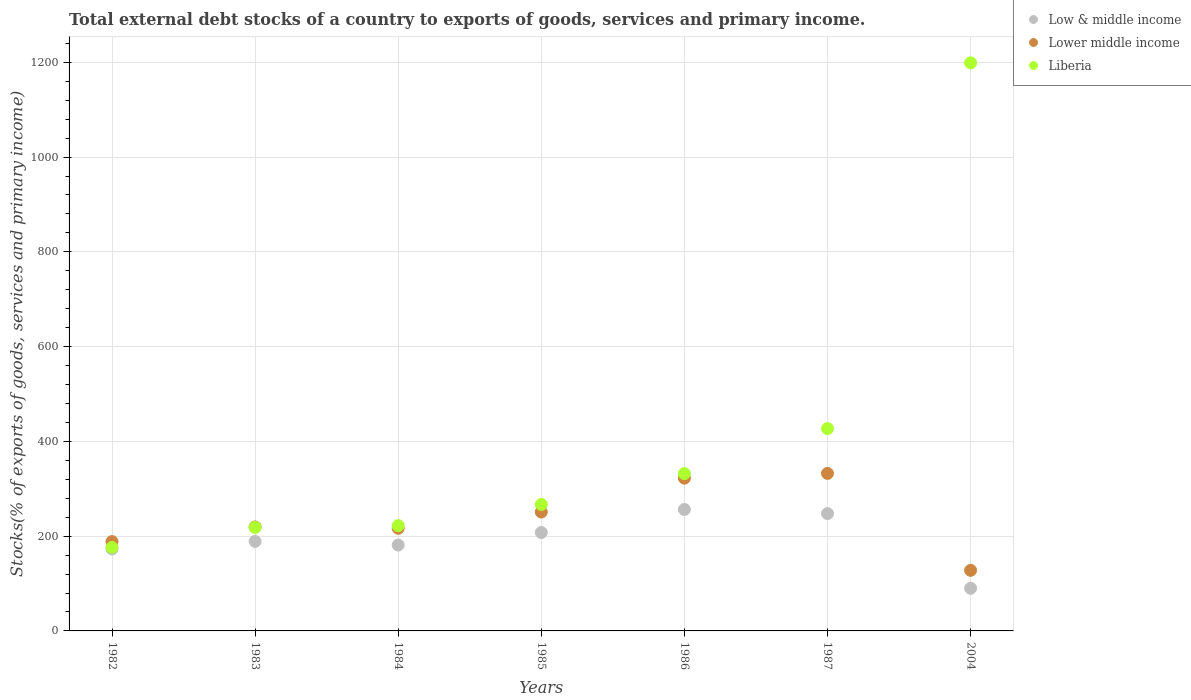What is the total debt stocks in Liberia in 1985?
Your answer should be compact. 266.74. Across all years, what is the maximum total debt stocks in Liberia?
Give a very brief answer. 1198.86. Across all years, what is the minimum total debt stocks in Liberia?
Provide a succinct answer. 176.26. In which year was the total debt stocks in Liberia maximum?
Make the answer very short. 2004. What is the total total debt stocks in Lower middle income in the graph?
Ensure brevity in your answer.  1658.04. What is the difference between the total debt stocks in Liberia in 1984 and that in 1985?
Give a very brief answer. -44.64. What is the difference between the total debt stocks in Lower middle income in 1985 and the total debt stocks in Liberia in 1987?
Offer a very short reply. -176.15. What is the average total debt stocks in Lower middle income per year?
Provide a short and direct response. 236.86. In the year 1982, what is the difference between the total debt stocks in Lower middle income and total debt stocks in Liberia?
Keep it short and to the point. 12.21. What is the ratio of the total debt stocks in Liberia in 1984 to that in 1986?
Offer a terse response. 0.67. Is the difference between the total debt stocks in Lower middle income in 1987 and 2004 greater than the difference between the total debt stocks in Liberia in 1987 and 2004?
Offer a very short reply. Yes. What is the difference between the highest and the second highest total debt stocks in Low & middle income?
Provide a short and direct response. 8.69. What is the difference between the highest and the lowest total debt stocks in Lower middle income?
Provide a succinct answer. 204.59. Is the sum of the total debt stocks in Low & middle income in 1984 and 2004 greater than the maximum total debt stocks in Lower middle income across all years?
Your response must be concise. No. Is the total debt stocks in Lower middle income strictly greater than the total debt stocks in Low & middle income over the years?
Your answer should be compact. Yes. Does the graph contain any zero values?
Provide a succinct answer. No. Does the graph contain grids?
Your response must be concise. Yes. Where does the legend appear in the graph?
Make the answer very short. Top right. How are the legend labels stacked?
Ensure brevity in your answer.  Vertical. What is the title of the graph?
Offer a terse response. Total external debt stocks of a country to exports of goods, services and primary income. Does "Moldova" appear as one of the legend labels in the graph?
Ensure brevity in your answer.  No. What is the label or title of the X-axis?
Your answer should be compact. Years. What is the label or title of the Y-axis?
Provide a succinct answer. Stocks(% of exports of goods, services and primary income). What is the Stocks(% of exports of goods, services and primary income) in Low & middle income in 1982?
Provide a succinct answer. 172.89. What is the Stocks(% of exports of goods, services and primary income) in Lower middle income in 1982?
Make the answer very short. 188.47. What is the Stocks(% of exports of goods, services and primary income) in Liberia in 1982?
Your answer should be very brief. 176.26. What is the Stocks(% of exports of goods, services and primary income) in Low & middle income in 1983?
Your answer should be compact. 188.9. What is the Stocks(% of exports of goods, services and primary income) of Lower middle income in 1983?
Provide a succinct answer. 219.51. What is the Stocks(% of exports of goods, services and primary income) in Liberia in 1983?
Your answer should be compact. 218.46. What is the Stocks(% of exports of goods, services and primary income) in Low & middle income in 1984?
Provide a short and direct response. 181.22. What is the Stocks(% of exports of goods, services and primary income) of Lower middle income in 1984?
Your answer should be very brief. 216.56. What is the Stocks(% of exports of goods, services and primary income) in Liberia in 1984?
Your answer should be compact. 222.1. What is the Stocks(% of exports of goods, services and primary income) in Low & middle income in 1985?
Offer a very short reply. 207.7. What is the Stocks(% of exports of goods, services and primary income) of Lower middle income in 1985?
Provide a succinct answer. 250.86. What is the Stocks(% of exports of goods, services and primary income) in Liberia in 1985?
Make the answer very short. 266.74. What is the Stocks(% of exports of goods, services and primary income) in Low & middle income in 1986?
Your answer should be compact. 256.34. What is the Stocks(% of exports of goods, services and primary income) in Lower middle income in 1986?
Provide a short and direct response. 322.36. What is the Stocks(% of exports of goods, services and primary income) in Liberia in 1986?
Ensure brevity in your answer.  331.94. What is the Stocks(% of exports of goods, services and primary income) of Low & middle income in 1987?
Provide a short and direct response. 247.65. What is the Stocks(% of exports of goods, services and primary income) in Lower middle income in 1987?
Offer a very short reply. 332.44. What is the Stocks(% of exports of goods, services and primary income) of Liberia in 1987?
Provide a succinct answer. 427.01. What is the Stocks(% of exports of goods, services and primary income) in Low & middle income in 2004?
Offer a terse response. 90.02. What is the Stocks(% of exports of goods, services and primary income) of Lower middle income in 2004?
Your answer should be compact. 127.84. What is the Stocks(% of exports of goods, services and primary income) in Liberia in 2004?
Your response must be concise. 1198.86. Across all years, what is the maximum Stocks(% of exports of goods, services and primary income) in Low & middle income?
Ensure brevity in your answer.  256.34. Across all years, what is the maximum Stocks(% of exports of goods, services and primary income) in Lower middle income?
Your response must be concise. 332.44. Across all years, what is the maximum Stocks(% of exports of goods, services and primary income) of Liberia?
Offer a terse response. 1198.86. Across all years, what is the minimum Stocks(% of exports of goods, services and primary income) of Low & middle income?
Keep it short and to the point. 90.02. Across all years, what is the minimum Stocks(% of exports of goods, services and primary income) in Lower middle income?
Make the answer very short. 127.84. Across all years, what is the minimum Stocks(% of exports of goods, services and primary income) in Liberia?
Keep it short and to the point. 176.26. What is the total Stocks(% of exports of goods, services and primary income) in Low & middle income in the graph?
Offer a very short reply. 1344.72. What is the total Stocks(% of exports of goods, services and primary income) of Lower middle income in the graph?
Keep it short and to the point. 1658.04. What is the total Stocks(% of exports of goods, services and primary income) of Liberia in the graph?
Your response must be concise. 2841.37. What is the difference between the Stocks(% of exports of goods, services and primary income) in Low & middle income in 1982 and that in 1983?
Your response must be concise. -16. What is the difference between the Stocks(% of exports of goods, services and primary income) in Lower middle income in 1982 and that in 1983?
Keep it short and to the point. -31.04. What is the difference between the Stocks(% of exports of goods, services and primary income) in Liberia in 1982 and that in 1983?
Provide a succinct answer. -42.2. What is the difference between the Stocks(% of exports of goods, services and primary income) of Low & middle income in 1982 and that in 1984?
Your answer should be very brief. -8.33. What is the difference between the Stocks(% of exports of goods, services and primary income) in Lower middle income in 1982 and that in 1984?
Ensure brevity in your answer.  -28.09. What is the difference between the Stocks(% of exports of goods, services and primary income) in Liberia in 1982 and that in 1984?
Offer a terse response. -45.84. What is the difference between the Stocks(% of exports of goods, services and primary income) of Low & middle income in 1982 and that in 1985?
Offer a terse response. -34.81. What is the difference between the Stocks(% of exports of goods, services and primary income) in Lower middle income in 1982 and that in 1985?
Ensure brevity in your answer.  -62.38. What is the difference between the Stocks(% of exports of goods, services and primary income) of Liberia in 1982 and that in 1985?
Offer a very short reply. -90.48. What is the difference between the Stocks(% of exports of goods, services and primary income) in Low & middle income in 1982 and that in 1986?
Offer a terse response. -83.44. What is the difference between the Stocks(% of exports of goods, services and primary income) of Lower middle income in 1982 and that in 1986?
Keep it short and to the point. -133.89. What is the difference between the Stocks(% of exports of goods, services and primary income) in Liberia in 1982 and that in 1986?
Make the answer very short. -155.68. What is the difference between the Stocks(% of exports of goods, services and primary income) of Low & middle income in 1982 and that in 1987?
Offer a very short reply. -74.75. What is the difference between the Stocks(% of exports of goods, services and primary income) of Lower middle income in 1982 and that in 1987?
Provide a succinct answer. -143.97. What is the difference between the Stocks(% of exports of goods, services and primary income) of Liberia in 1982 and that in 1987?
Offer a very short reply. -250.74. What is the difference between the Stocks(% of exports of goods, services and primary income) of Low & middle income in 1982 and that in 2004?
Your answer should be very brief. 82.87. What is the difference between the Stocks(% of exports of goods, services and primary income) in Lower middle income in 1982 and that in 2004?
Offer a very short reply. 60.63. What is the difference between the Stocks(% of exports of goods, services and primary income) in Liberia in 1982 and that in 2004?
Your answer should be compact. -1022.6. What is the difference between the Stocks(% of exports of goods, services and primary income) of Low & middle income in 1983 and that in 1984?
Provide a succinct answer. 7.68. What is the difference between the Stocks(% of exports of goods, services and primary income) of Lower middle income in 1983 and that in 1984?
Your response must be concise. 2.95. What is the difference between the Stocks(% of exports of goods, services and primary income) of Liberia in 1983 and that in 1984?
Keep it short and to the point. -3.64. What is the difference between the Stocks(% of exports of goods, services and primary income) of Low & middle income in 1983 and that in 1985?
Offer a very short reply. -18.8. What is the difference between the Stocks(% of exports of goods, services and primary income) in Lower middle income in 1983 and that in 1985?
Give a very brief answer. -31.34. What is the difference between the Stocks(% of exports of goods, services and primary income) of Liberia in 1983 and that in 1985?
Provide a succinct answer. -48.28. What is the difference between the Stocks(% of exports of goods, services and primary income) of Low & middle income in 1983 and that in 1986?
Your answer should be very brief. -67.44. What is the difference between the Stocks(% of exports of goods, services and primary income) in Lower middle income in 1983 and that in 1986?
Offer a terse response. -102.85. What is the difference between the Stocks(% of exports of goods, services and primary income) in Liberia in 1983 and that in 1986?
Your answer should be very brief. -113.47. What is the difference between the Stocks(% of exports of goods, services and primary income) in Low & middle income in 1983 and that in 1987?
Offer a terse response. -58.75. What is the difference between the Stocks(% of exports of goods, services and primary income) of Lower middle income in 1983 and that in 1987?
Give a very brief answer. -112.93. What is the difference between the Stocks(% of exports of goods, services and primary income) in Liberia in 1983 and that in 1987?
Offer a terse response. -208.54. What is the difference between the Stocks(% of exports of goods, services and primary income) in Low & middle income in 1983 and that in 2004?
Give a very brief answer. 98.87. What is the difference between the Stocks(% of exports of goods, services and primary income) in Lower middle income in 1983 and that in 2004?
Provide a short and direct response. 91.67. What is the difference between the Stocks(% of exports of goods, services and primary income) in Liberia in 1983 and that in 2004?
Offer a terse response. -980.4. What is the difference between the Stocks(% of exports of goods, services and primary income) of Low & middle income in 1984 and that in 1985?
Provide a succinct answer. -26.48. What is the difference between the Stocks(% of exports of goods, services and primary income) in Lower middle income in 1984 and that in 1985?
Offer a very short reply. -34.29. What is the difference between the Stocks(% of exports of goods, services and primary income) in Liberia in 1984 and that in 1985?
Provide a short and direct response. -44.64. What is the difference between the Stocks(% of exports of goods, services and primary income) of Low & middle income in 1984 and that in 1986?
Offer a terse response. -75.11. What is the difference between the Stocks(% of exports of goods, services and primary income) in Lower middle income in 1984 and that in 1986?
Provide a succinct answer. -105.8. What is the difference between the Stocks(% of exports of goods, services and primary income) in Liberia in 1984 and that in 1986?
Your response must be concise. -109.83. What is the difference between the Stocks(% of exports of goods, services and primary income) in Low & middle income in 1984 and that in 1987?
Your response must be concise. -66.42. What is the difference between the Stocks(% of exports of goods, services and primary income) in Lower middle income in 1984 and that in 1987?
Offer a very short reply. -115.88. What is the difference between the Stocks(% of exports of goods, services and primary income) of Liberia in 1984 and that in 1987?
Your response must be concise. -204.9. What is the difference between the Stocks(% of exports of goods, services and primary income) of Low & middle income in 1984 and that in 2004?
Your answer should be compact. 91.2. What is the difference between the Stocks(% of exports of goods, services and primary income) in Lower middle income in 1984 and that in 2004?
Ensure brevity in your answer.  88.72. What is the difference between the Stocks(% of exports of goods, services and primary income) in Liberia in 1984 and that in 2004?
Offer a terse response. -976.76. What is the difference between the Stocks(% of exports of goods, services and primary income) of Low & middle income in 1985 and that in 1986?
Your answer should be very brief. -48.63. What is the difference between the Stocks(% of exports of goods, services and primary income) of Lower middle income in 1985 and that in 1986?
Offer a terse response. -71.5. What is the difference between the Stocks(% of exports of goods, services and primary income) of Liberia in 1985 and that in 1986?
Offer a very short reply. -65.2. What is the difference between the Stocks(% of exports of goods, services and primary income) in Low & middle income in 1985 and that in 1987?
Provide a short and direct response. -39.94. What is the difference between the Stocks(% of exports of goods, services and primary income) in Lower middle income in 1985 and that in 1987?
Your answer should be compact. -81.58. What is the difference between the Stocks(% of exports of goods, services and primary income) of Liberia in 1985 and that in 1987?
Provide a succinct answer. -160.27. What is the difference between the Stocks(% of exports of goods, services and primary income) in Low & middle income in 1985 and that in 2004?
Make the answer very short. 117.68. What is the difference between the Stocks(% of exports of goods, services and primary income) of Lower middle income in 1985 and that in 2004?
Give a very brief answer. 123.01. What is the difference between the Stocks(% of exports of goods, services and primary income) of Liberia in 1985 and that in 2004?
Your answer should be very brief. -932.12. What is the difference between the Stocks(% of exports of goods, services and primary income) in Low & middle income in 1986 and that in 1987?
Make the answer very short. 8.69. What is the difference between the Stocks(% of exports of goods, services and primary income) in Lower middle income in 1986 and that in 1987?
Offer a terse response. -10.08. What is the difference between the Stocks(% of exports of goods, services and primary income) in Liberia in 1986 and that in 1987?
Provide a succinct answer. -95.07. What is the difference between the Stocks(% of exports of goods, services and primary income) in Low & middle income in 1986 and that in 2004?
Ensure brevity in your answer.  166.31. What is the difference between the Stocks(% of exports of goods, services and primary income) in Lower middle income in 1986 and that in 2004?
Ensure brevity in your answer.  194.51. What is the difference between the Stocks(% of exports of goods, services and primary income) in Liberia in 1986 and that in 2004?
Your answer should be compact. -866.92. What is the difference between the Stocks(% of exports of goods, services and primary income) in Low & middle income in 1987 and that in 2004?
Provide a short and direct response. 157.62. What is the difference between the Stocks(% of exports of goods, services and primary income) in Lower middle income in 1987 and that in 2004?
Your answer should be very brief. 204.59. What is the difference between the Stocks(% of exports of goods, services and primary income) in Liberia in 1987 and that in 2004?
Provide a succinct answer. -771.85. What is the difference between the Stocks(% of exports of goods, services and primary income) in Low & middle income in 1982 and the Stocks(% of exports of goods, services and primary income) in Lower middle income in 1983?
Make the answer very short. -46.62. What is the difference between the Stocks(% of exports of goods, services and primary income) of Low & middle income in 1982 and the Stocks(% of exports of goods, services and primary income) of Liberia in 1983?
Offer a very short reply. -45.57. What is the difference between the Stocks(% of exports of goods, services and primary income) in Lower middle income in 1982 and the Stocks(% of exports of goods, services and primary income) in Liberia in 1983?
Keep it short and to the point. -29.99. What is the difference between the Stocks(% of exports of goods, services and primary income) in Low & middle income in 1982 and the Stocks(% of exports of goods, services and primary income) in Lower middle income in 1984?
Offer a terse response. -43.67. What is the difference between the Stocks(% of exports of goods, services and primary income) of Low & middle income in 1982 and the Stocks(% of exports of goods, services and primary income) of Liberia in 1984?
Provide a succinct answer. -49.21. What is the difference between the Stocks(% of exports of goods, services and primary income) of Lower middle income in 1982 and the Stocks(% of exports of goods, services and primary income) of Liberia in 1984?
Provide a short and direct response. -33.63. What is the difference between the Stocks(% of exports of goods, services and primary income) in Low & middle income in 1982 and the Stocks(% of exports of goods, services and primary income) in Lower middle income in 1985?
Provide a short and direct response. -77.96. What is the difference between the Stocks(% of exports of goods, services and primary income) of Low & middle income in 1982 and the Stocks(% of exports of goods, services and primary income) of Liberia in 1985?
Provide a succinct answer. -93.84. What is the difference between the Stocks(% of exports of goods, services and primary income) of Lower middle income in 1982 and the Stocks(% of exports of goods, services and primary income) of Liberia in 1985?
Keep it short and to the point. -78.27. What is the difference between the Stocks(% of exports of goods, services and primary income) in Low & middle income in 1982 and the Stocks(% of exports of goods, services and primary income) in Lower middle income in 1986?
Provide a succinct answer. -149.46. What is the difference between the Stocks(% of exports of goods, services and primary income) of Low & middle income in 1982 and the Stocks(% of exports of goods, services and primary income) of Liberia in 1986?
Keep it short and to the point. -159.04. What is the difference between the Stocks(% of exports of goods, services and primary income) of Lower middle income in 1982 and the Stocks(% of exports of goods, services and primary income) of Liberia in 1986?
Provide a short and direct response. -143.46. What is the difference between the Stocks(% of exports of goods, services and primary income) of Low & middle income in 1982 and the Stocks(% of exports of goods, services and primary income) of Lower middle income in 1987?
Provide a short and direct response. -159.54. What is the difference between the Stocks(% of exports of goods, services and primary income) in Low & middle income in 1982 and the Stocks(% of exports of goods, services and primary income) in Liberia in 1987?
Your response must be concise. -254.11. What is the difference between the Stocks(% of exports of goods, services and primary income) in Lower middle income in 1982 and the Stocks(% of exports of goods, services and primary income) in Liberia in 1987?
Provide a succinct answer. -238.53. What is the difference between the Stocks(% of exports of goods, services and primary income) in Low & middle income in 1982 and the Stocks(% of exports of goods, services and primary income) in Lower middle income in 2004?
Provide a short and direct response. 45.05. What is the difference between the Stocks(% of exports of goods, services and primary income) of Low & middle income in 1982 and the Stocks(% of exports of goods, services and primary income) of Liberia in 2004?
Give a very brief answer. -1025.96. What is the difference between the Stocks(% of exports of goods, services and primary income) of Lower middle income in 1982 and the Stocks(% of exports of goods, services and primary income) of Liberia in 2004?
Give a very brief answer. -1010.39. What is the difference between the Stocks(% of exports of goods, services and primary income) in Low & middle income in 1983 and the Stocks(% of exports of goods, services and primary income) in Lower middle income in 1984?
Provide a short and direct response. -27.66. What is the difference between the Stocks(% of exports of goods, services and primary income) in Low & middle income in 1983 and the Stocks(% of exports of goods, services and primary income) in Liberia in 1984?
Offer a terse response. -33.2. What is the difference between the Stocks(% of exports of goods, services and primary income) of Lower middle income in 1983 and the Stocks(% of exports of goods, services and primary income) of Liberia in 1984?
Your answer should be very brief. -2.59. What is the difference between the Stocks(% of exports of goods, services and primary income) of Low & middle income in 1983 and the Stocks(% of exports of goods, services and primary income) of Lower middle income in 1985?
Provide a succinct answer. -61.96. What is the difference between the Stocks(% of exports of goods, services and primary income) in Low & middle income in 1983 and the Stocks(% of exports of goods, services and primary income) in Liberia in 1985?
Give a very brief answer. -77.84. What is the difference between the Stocks(% of exports of goods, services and primary income) of Lower middle income in 1983 and the Stocks(% of exports of goods, services and primary income) of Liberia in 1985?
Offer a terse response. -47.23. What is the difference between the Stocks(% of exports of goods, services and primary income) of Low & middle income in 1983 and the Stocks(% of exports of goods, services and primary income) of Lower middle income in 1986?
Provide a short and direct response. -133.46. What is the difference between the Stocks(% of exports of goods, services and primary income) in Low & middle income in 1983 and the Stocks(% of exports of goods, services and primary income) in Liberia in 1986?
Your answer should be very brief. -143.04. What is the difference between the Stocks(% of exports of goods, services and primary income) of Lower middle income in 1983 and the Stocks(% of exports of goods, services and primary income) of Liberia in 1986?
Offer a very short reply. -112.42. What is the difference between the Stocks(% of exports of goods, services and primary income) in Low & middle income in 1983 and the Stocks(% of exports of goods, services and primary income) in Lower middle income in 1987?
Make the answer very short. -143.54. What is the difference between the Stocks(% of exports of goods, services and primary income) in Low & middle income in 1983 and the Stocks(% of exports of goods, services and primary income) in Liberia in 1987?
Ensure brevity in your answer.  -238.11. What is the difference between the Stocks(% of exports of goods, services and primary income) in Lower middle income in 1983 and the Stocks(% of exports of goods, services and primary income) in Liberia in 1987?
Make the answer very short. -207.49. What is the difference between the Stocks(% of exports of goods, services and primary income) in Low & middle income in 1983 and the Stocks(% of exports of goods, services and primary income) in Lower middle income in 2004?
Offer a very short reply. 61.05. What is the difference between the Stocks(% of exports of goods, services and primary income) of Low & middle income in 1983 and the Stocks(% of exports of goods, services and primary income) of Liberia in 2004?
Provide a short and direct response. -1009.96. What is the difference between the Stocks(% of exports of goods, services and primary income) in Lower middle income in 1983 and the Stocks(% of exports of goods, services and primary income) in Liberia in 2004?
Provide a succinct answer. -979.35. What is the difference between the Stocks(% of exports of goods, services and primary income) of Low & middle income in 1984 and the Stocks(% of exports of goods, services and primary income) of Lower middle income in 1985?
Keep it short and to the point. -69.63. What is the difference between the Stocks(% of exports of goods, services and primary income) of Low & middle income in 1984 and the Stocks(% of exports of goods, services and primary income) of Liberia in 1985?
Provide a succinct answer. -85.52. What is the difference between the Stocks(% of exports of goods, services and primary income) in Lower middle income in 1984 and the Stocks(% of exports of goods, services and primary income) in Liberia in 1985?
Offer a very short reply. -50.18. What is the difference between the Stocks(% of exports of goods, services and primary income) in Low & middle income in 1984 and the Stocks(% of exports of goods, services and primary income) in Lower middle income in 1986?
Provide a succinct answer. -141.14. What is the difference between the Stocks(% of exports of goods, services and primary income) in Low & middle income in 1984 and the Stocks(% of exports of goods, services and primary income) in Liberia in 1986?
Keep it short and to the point. -150.71. What is the difference between the Stocks(% of exports of goods, services and primary income) of Lower middle income in 1984 and the Stocks(% of exports of goods, services and primary income) of Liberia in 1986?
Keep it short and to the point. -115.37. What is the difference between the Stocks(% of exports of goods, services and primary income) in Low & middle income in 1984 and the Stocks(% of exports of goods, services and primary income) in Lower middle income in 1987?
Offer a terse response. -151.22. What is the difference between the Stocks(% of exports of goods, services and primary income) in Low & middle income in 1984 and the Stocks(% of exports of goods, services and primary income) in Liberia in 1987?
Offer a very short reply. -245.78. What is the difference between the Stocks(% of exports of goods, services and primary income) of Lower middle income in 1984 and the Stocks(% of exports of goods, services and primary income) of Liberia in 1987?
Your answer should be compact. -210.44. What is the difference between the Stocks(% of exports of goods, services and primary income) of Low & middle income in 1984 and the Stocks(% of exports of goods, services and primary income) of Lower middle income in 2004?
Ensure brevity in your answer.  53.38. What is the difference between the Stocks(% of exports of goods, services and primary income) of Low & middle income in 1984 and the Stocks(% of exports of goods, services and primary income) of Liberia in 2004?
Your answer should be very brief. -1017.64. What is the difference between the Stocks(% of exports of goods, services and primary income) of Lower middle income in 1984 and the Stocks(% of exports of goods, services and primary income) of Liberia in 2004?
Your answer should be compact. -982.3. What is the difference between the Stocks(% of exports of goods, services and primary income) in Low & middle income in 1985 and the Stocks(% of exports of goods, services and primary income) in Lower middle income in 1986?
Offer a terse response. -114.66. What is the difference between the Stocks(% of exports of goods, services and primary income) in Low & middle income in 1985 and the Stocks(% of exports of goods, services and primary income) in Liberia in 1986?
Keep it short and to the point. -124.23. What is the difference between the Stocks(% of exports of goods, services and primary income) of Lower middle income in 1985 and the Stocks(% of exports of goods, services and primary income) of Liberia in 1986?
Provide a succinct answer. -81.08. What is the difference between the Stocks(% of exports of goods, services and primary income) of Low & middle income in 1985 and the Stocks(% of exports of goods, services and primary income) of Lower middle income in 1987?
Provide a short and direct response. -124.74. What is the difference between the Stocks(% of exports of goods, services and primary income) of Low & middle income in 1985 and the Stocks(% of exports of goods, services and primary income) of Liberia in 1987?
Your answer should be compact. -219.3. What is the difference between the Stocks(% of exports of goods, services and primary income) in Lower middle income in 1985 and the Stocks(% of exports of goods, services and primary income) in Liberia in 1987?
Ensure brevity in your answer.  -176.15. What is the difference between the Stocks(% of exports of goods, services and primary income) in Low & middle income in 1985 and the Stocks(% of exports of goods, services and primary income) in Lower middle income in 2004?
Provide a succinct answer. 79.86. What is the difference between the Stocks(% of exports of goods, services and primary income) in Low & middle income in 1985 and the Stocks(% of exports of goods, services and primary income) in Liberia in 2004?
Your answer should be compact. -991.16. What is the difference between the Stocks(% of exports of goods, services and primary income) in Lower middle income in 1985 and the Stocks(% of exports of goods, services and primary income) in Liberia in 2004?
Your answer should be compact. -948. What is the difference between the Stocks(% of exports of goods, services and primary income) in Low & middle income in 1986 and the Stocks(% of exports of goods, services and primary income) in Lower middle income in 1987?
Your response must be concise. -76.1. What is the difference between the Stocks(% of exports of goods, services and primary income) in Low & middle income in 1986 and the Stocks(% of exports of goods, services and primary income) in Liberia in 1987?
Provide a short and direct response. -170.67. What is the difference between the Stocks(% of exports of goods, services and primary income) of Lower middle income in 1986 and the Stocks(% of exports of goods, services and primary income) of Liberia in 1987?
Your answer should be very brief. -104.65. What is the difference between the Stocks(% of exports of goods, services and primary income) of Low & middle income in 1986 and the Stocks(% of exports of goods, services and primary income) of Lower middle income in 2004?
Your answer should be very brief. 128.49. What is the difference between the Stocks(% of exports of goods, services and primary income) of Low & middle income in 1986 and the Stocks(% of exports of goods, services and primary income) of Liberia in 2004?
Make the answer very short. -942.52. What is the difference between the Stocks(% of exports of goods, services and primary income) of Lower middle income in 1986 and the Stocks(% of exports of goods, services and primary income) of Liberia in 2004?
Keep it short and to the point. -876.5. What is the difference between the Stocks(% of exports of goods, services and primary income) in Low & middle income in 1987 and the Stocks(% of exports of goods, services and primary income) in Lower middle income in 2004?
Your answer should be compact. 119.8. What is the difference between the Stocks(% of exports of goods, services and primary income) in Low & middle income in 1987 and the Stocks(% of exports of goods, services and primary income) in Liberia in 2004?
Your response must be concise. -951.21. What is the difference between the Stocks(% of exports of goods, services and primary income) in Lower middle income in 1987 and the Stocks(% of exports of goods, services and primary income) in Liberia in 2004?
Provide a short and direct response. -866.42. What is the average Stocks(% of exports of goods, services and primary income) of Low & middle income per year?
Your answer should be compact. 192.1. What is the average Stocks(% of exports of goods, services and primary income) in Lower middle income per year?
Your answer should be very brief. 236.86. What is the average Stocks(% of exports of goods, services and primary income) of Liberia per year?
Offer a terse response. 405.91. In the year 1982, what is the difference between the Stocks(% of exports of goods, services and primary income) in Low & middle income and Stocks(% of exports of goods, services and primary income) in Lower middle income?
Provide a succinct answer. -15.58. In the year 1982, what is the difference between the Stocks(% of exports of goods, services and primary income) of Low & middle income and Stocks(% of exports of goods, services and primary income) of Liberia?
Give a very brief answer. -3.37. In the year 1982, what is the difference between the Stocks(% of exports of goods, services and primary income) of Lower middle income and Stocks(% of exports of goods, services and primary income) of Liberia?
Make the answer very short. 12.21. In the year 1983, what is the difference between the Stocks(% of exports of goods, services and primary income) of Low & middle income and Stocks(% of exports of goods, services and primary income) of Lower middle income?
Your answer should be very brief. -30.61. In the year 1983, what is the difference between the Stocks(% of exports of goods, services and primary income) of Low & middle income and Stocks(% of exports of goods, services and primary income) of Liberia?
Make the answer very short. -29.56. In the year 1983, what is the difference between the Stocks(% of exports of goods, services and primary income) in Lower middle income and Stocks(% of exports of goods, services and primary income) in Liberia?
Your answer should be very brief. 1.05. In the year 1984, what is the difference between the Stocks(% of exports of goods, services and primary income) of Low & middle income and Stocks(% of exports of goods, services and primary income) of Lower middle income?
Ensure brevity in your answer.  -35.34. In the year 1984, what is the difference between the Stocks(% of exports of goods, services and primary income) in Low & middle income and Stocks(% of exports of goods, services and primary income) in Liberia?
Offer a terse response. -40.88. In the year 1984, what is the difference between the Stocks(% of exports of goods, services and primary income) in Lower middle income and Stocks(% of exports of goods, services and primary income) in Liberia?
Give a very brief answer. -5.54. In the year 1985, what is the difference between the Stocks(% of exports of goods, services and primary income) of Low & middle income and Stocks(% of exports of goods, services and primary income) of Lower middle income?
Your response must be concise. -43.15. In the year 1985, what is the difference between the Stocks(% of exports of goods, services and primary income) of Low & middle income and Stocks(% of exports of goods, services and primary income) of Liberia?
Give a very brief answer. -59.04. In the year 1985, what is the difference between the Stocks(% of exports of goods, services and primary income) in Lower middle income and Stocks(% of exports of goods, services and primary income) in Liberia?
Keep it short and to the point. -15.88. In the year 1986, what is the difference between the Stocks(% of exports of goods, services and primary income) of Low & middle income and Stocks(% of exports of goods, services and primary income) of Lower middle income?
Ensure brevity in your answer.  -66.02. In the year 1986, what is the difference between the Stocks(% of exports of goods, services and primary income) in Low & middle income and Stocks(% of exports of goods, services and primary income) in Liberia?
Make the answer very short. -75.6. In the year 1986, what is the difference between the Stocks(% of exports of goods, services and primary income) of Lower middle income and Stocks(% of exports of goods, services and primary income) of Liberia?
Ensure brevity in your answer.  -9.58. In the year 1987, what is the difference between the Stocks(% of exports of goods, services and primary income) in Low & middle income and Stocks(% of exports of goods, services and primary income) in Lower middle income?
Your response must be concise. -84.79. In the year 1987, what is the difference between the Stocks(% of exports of goods, services and primary income) in Low & middle income and Stocks(% of exports of goods, services and primary income) in Liberia?
Offer a very short reply. -179.36. In the year 1987, what is the difference between the Stocks(% of exports of goods, services and primary income) in Lower middle income and Stocks(% of exports of goods, services and primary income) in Liberia?
Offer a terse response. -94.57. In the year 2004, what is the difference between the Stocks(% of exports of goods, services and primary income) of Low & middle income and Stocks(% of exports of goods, services and primary income) of Lower middle income?
Your response must be concise. -37.82. In the year 2004, what is the difference between the Stocks(% of exports of goods, services and primary income) of Low & middle income and Stocks(% of exports of goods, services and primary income) of Liberia?
Ensure brevity in your answer.  -1108.84. In the year 2004, what is the difference between the Stocks(% of exports of goods, services and primary income) in Lower middle income and Stocks(% of exports of goods, services and primary income) in Liberia?
Your answer should be very brief. -1071.01. What is the ratio of the Stocks(% of exports of goods, services and primary income) in Low & middle income in 1982 to that in 1983?
Your answer should be very brief. 0.92. What is the ratio of the Stocks(% of exports of goods, services and primary income) in Lower middle income in 1982 to that in 1983?
Offer a terse response. 0.86. What is the ratio of the Stocks(% of exports of goods, services and primary income) of Liberia in 1982 to that in 1983?
Offer a very short reply. 0.81. What is the ratio of the Stocks(% of exports of goods, services and primary income) in Low & middle income in 1982 to that in 1984?
Offer a very short reply. 0.95. What is the ratio of the Stocks(% of exports of goods, services and primary income) in Lower middle income in 1982 to that in 1984?
Give a very brief answer. 0.87. What is the ratio of the Stocks(% of exports of goods, services and primary income) in Liberia in 1982 to that in 1984?
Your answer should be compact. 0.79. What is the ratio of the Stocks(% of exports of goods, services and primary income) in Low & middle income in 1982 to that in 1985?
Offer a terse response. 0.83. What is the ratio of the Stocks(% of exports of goods, services and primary income) in Lower middle income in 1982 to that in 1985?
Your answer should be compact. 0.75. What is the ratio of the Stocks(% of exports of goods, services and primary income) in Liberia in 1982 to that in 1985?
Offer a very short reply. 0.66. What is the ratio of the Stocks(% of exports of goods, services and primary income) in Low & middle income in 1982 to that in 1986?
Your answer should be compact. 0.67. What is the ratio of the Stocks(% of exports of goods, services and primary income) in Lower middle income in 1982 to that in 1986?
Provide a short and direct response. 0.58. What is the ratio of the Stocks(% of exports of goods, services and primary income) of Liberia in 1982 to that in 1986?
Offer a terse response. 0.53. What is the ratio of the Stocks(% of exports of goods, services and primary income) of Low & middle income in 1982 to that in 1987?
Provide a succinct answer. 0.7. What is the ratio of the Stocks(% of exports of goods, services and primary income) of Lower middle income in 1982 to that in 1987?
Offer a terse response. 0.57. What is the ratio of the Stocks(% of exports of goods, services and primary income) in Liberia in 1982 to that in 1987?
Your answer should be very brief. 0.41. What is the ratio of the Stocks(% of exports of goods, services and primary income) in Low & middle income in 1982 to that in 2004?
Provide a short and direct response. 1.92. What is the ratio of the Stocks(% of exports of goods, services and primary income) in Lower middle income in 1982 to that in 2004?
Offer a very short reply. 1.47. What is the ratio of the Stocks(% of exports of goods, services and primary income) in Liberia in 1982 to that in 2004?
Keep it short and to the point. 0.15. What is the ratio of the Stocks(% of exports of goods, services and primary income) in Low & middle income in 1983 to that in 1984?
Provide a succinct answer. 1.04. What is the ratio of the Stocks(% of exports of goods, services and primary income) in Lower middle income in 1983 to that in 1984?
Give a very brief answer. 1.01. What is the ratio of the Stocks(% of exports of goods, services and primary income) in Liberia in 1983 to that in 1984?
Your response must be concise. 0.98. What is the ratio of the Stocks(% of exports of goods, services and primary income) in Low & middle income in 1983 to that in 1985?
Your answer should be very brief. 0.91. What is the ratio of the Stocks(% of exports of goods, services and primary income) of Lower middle income in 1983 to that in 1985?
Offer a very short reply. 0.88. What is the ratio of the Stocks(% of exports of goods, services and primary income) of Liberia in 1983 to that in 1985?
Offer a terse response. 0.82. What is the ratio of the Stocks(% of exports of goods, services and primary income) of Low & middle income in 1983 to that in 1986?
Your answer should be very brief. 0.74. What is the ratio of the Stocks(% of exports of goods, services and primary income) in Lower middle income in 1983 to that in 1986?
Make the answer very short. 0.68. What is the ratio of the Stocks(% of exports of goods, services and primary income) of Liberia in 1983 to that in 1986?
Offer a terse response. 0.66. What is the ratio of the Stocks(% of exports of goods, services and primary income) of Low & middle income in 1983 to that in 1987?
Keep it short and to the point. 0.76. What is the ratio of the Stocks(% of exports of goods, services and primary income) in Lower middle income in 1983 to that in 1987?
Offer a terse response. 0.66. What is the ratio of the Stocks(% of exports of goods, services and primary income) of Liberia in 1983 to that in 1987?
Your answer should be compact. 0.51. What is the ratio of the Stocks(% of exports of goods, services and primary income) in Low & middle income in 1983 to that in 2004?
Offer a terse response. 2.1. What is the ratio of the Stocks(% of exports of goods, services and primary income) in Lower middle income in 1983 to that in 2004?
Offer a very short reply. 1.72. What is the ratio of the Stocks(% of exports of goods, services and primary income) of Liberia in 1983 to that in 2004?
Your response must be concise. 0.18. What is the ratio of the Stocks(% of exports of goods, services and primary income) of Low & middle income in 1984 to that in 1985?
Your answer should be compact. 0.87. What is the ratio of the Stocks(% of exports of goods, services and primary income) of Lower middle income in 1984 to that in 1985?
Give a very brief answer. 0.86. What is the ratio of the Stocks(% of exports of goods, services and primary income) of Liberia in 1984 to that in 1985?
Give a very brief answer. 0.83. What is the ratio of the Stocks(% of exports of goods, services and primary income) in Low & middle income in 1984 to that in 1986?
Offer a very short reply. 0.71. What is the ratio of the Stocks(% of exports of goods, services and primary income) in Lower middle income in 1984 to that in 1986?
Give a very brief answer. 0.67. What is the ratio of the Stocks(% of exports of goods, services and primary income) of Liberia in 1984 to that in 1986?
Keep it short and to the point. 0.67. What is the ratio of the Stocks(% of exports of goods, services and primary income) of Low & middle income in 1984 to that in 1987?
Give a very brief answer. 0.73. What is the ratio of the Stocks(% of exports of goods, services and primary income) in Lower middle income in 1984 to that in 1987?
Make the answer very short. 0.65. What is the ratio of the Stocks(% of exports of goods, services and primary income) in Liberia in 1984 to that in 1987?
Your response must be concise. 0.52. What is the ratio of the Stocks(% of exports of goods, services and primary income) of Low & middle income in 1984 to that in 2004?
Make the answer very short. 2.01. What is the ratio of the Stocks(% of exports of goods, services and primary income) of Lower middle income in 1984 to that in 2004?
Make the answer very short. 1.69. What is the ratio of the Stocks(% of exports of goods, services and primary income) of Liberia in 1984 to that in 2004?
Offer a very short reply. 0.19. What is the ratio of the Stocks(% of exports of goods, services and primary income) in Low & middle income in 1985 to that in 1986?
Your answer should be very brief. 0.81. What is the ratio of the Stocks(% of exports of goods, services and primary income) of Lower middle income in 1985 to that in 1986?
Your response must be concise. 0.78. What is the ratio of the Stocks(% of exports of goods, services and primary income) of Liberia in 1985 to that in 1986?
Ensure brevity in your answer.  0.8. What is the ratio of the Stocks(% of exports of goods, services and primary income) of Low & middle income in 1985 to that in 1987?
Offer a very short reply. 0.84. What is the ratio of the Stocks(% of exports of goods, services and primary income) of Lower middle income in 1985 to that in 1987?
Your answer should be very brief. 0.75. What is the ratio of the Stocks(% of exports of goods, services and primary income) of Liberia in 1985 to that in 1987?
Your answer should be very brief. 0.62. What is the ratio of the Stocks(% of exports of goods, services and primary income) in Low & middle income in 1985 to that in 2004?
Ensure brevity in your answer.  2.31. What is the ratio of the Stocks(% of exports of goods, services and primary income) in Lower middle income in 1985 to that in 2004?
Offer a terse response. 1.96. What is the ratio of the Stocks(% of exports of goods, services and primary income) in Liberia in 1985 to that in 2004?
Your answer should be compact. 0.22. What is the ratio of the Stocks(% of exports of goods, services and primary income) of Low & middle income in 1986 to that in 1987?
Offer a terse response. 1.04. What is the ratio of the Stocks(% of exports of goods, services and primary income) in Lower middle income in 1986 to that in 1987?
Your answer should be very brief. 0.97. What is the ratio of the Stocks(% of exports of goods, services and primary income) in Liberia in 1986 to that in 1987?
Keep it short and to the point. 0.78. What is the ratio of the Stocks(% of exports of goods, services and primary income) in Low & middle income in 1986 to that in 2004?
Provide a short and direct response. 2.85. What is the ratio of the Stocks(% of exports of goods, services and primary income) in Lower middle income in 1986 to that in 2004?
Your response must be concise. 2.52. What is the ratio of the Stocks(% of exports of goods, services and primary income) in Liberia in 1986 to that in 2004?
Your answer should be very brief. 0.28. What is the ratio of the Stocks(% of exports of goods, services and primary income) in Low & middle income in 1987 to that in 2004?
Your answer should be very brief. 2.75. What is the ratio of the Stocks(% of exports of goods, services and primary income) in Lower middle income in 1987 to that in 2004?
Your answer should be very brief. 2.6. What is the ratio of the Stocks(% of exports of goods, services and primary income) of Liberia in 1987 to that in 2004?
Ensure brevity in your answer.  0.36. What is the difference between the highest and the second highest Stocks(% of exports of goods, services and primary income) in Low & middle income?
Your answer should be very brief. 8.69. What is the difference between the highest and the second highest Stocks(% of exports of goods, services and primary income) in Lower middle income?
Offer a very short reply. 10.08. What is the difference between the highest and the second highest Stocks(% of exports of goods, services and primary income) in Liberia?
Your response must be concise. 771.85. What is the difference between the highest and the lowest Stocks(% of exports of goods, services and primary income) of Low & middle income?
Offer a terse response. 166.31. What is the difference between the highest and the lowest Stocks(% of exports of goods, services and primary income) in Lower middle income?
Offer a terse response. 204.59. What is the difference between the highest and the lowest Stocks(% of exports of goods, services and primary income) in Liberia?
Your response must be concise. 1022.6. 